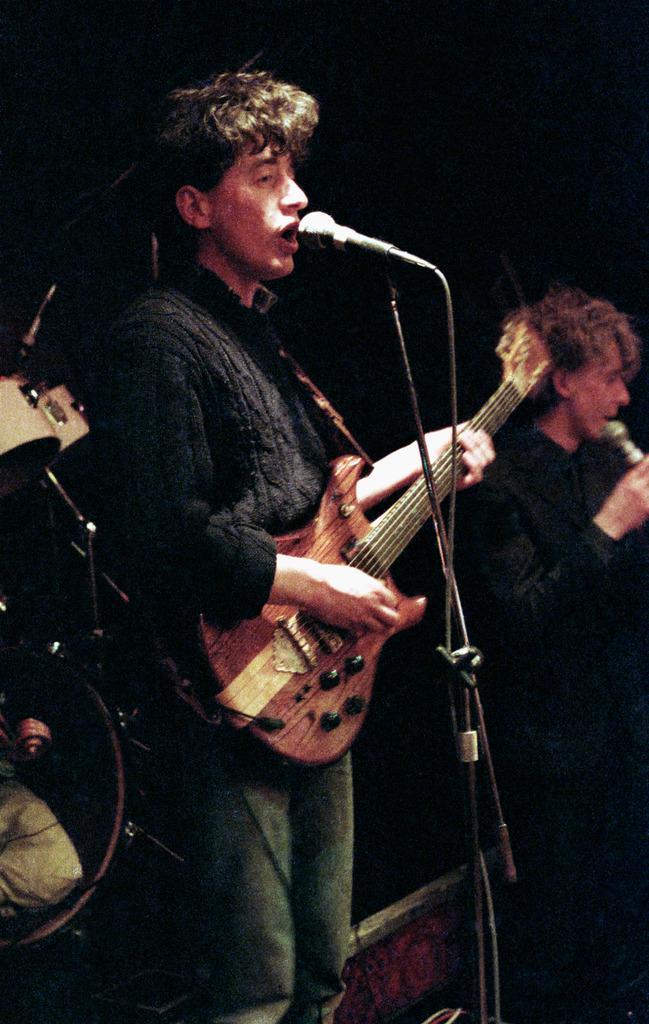Please provide a concise description of this image. In this picture a guy is playing a guitar and singing through a mic placed in front of him. We also observed musicians to the right side of the image. There are also musical instruments to the right side of the image. 